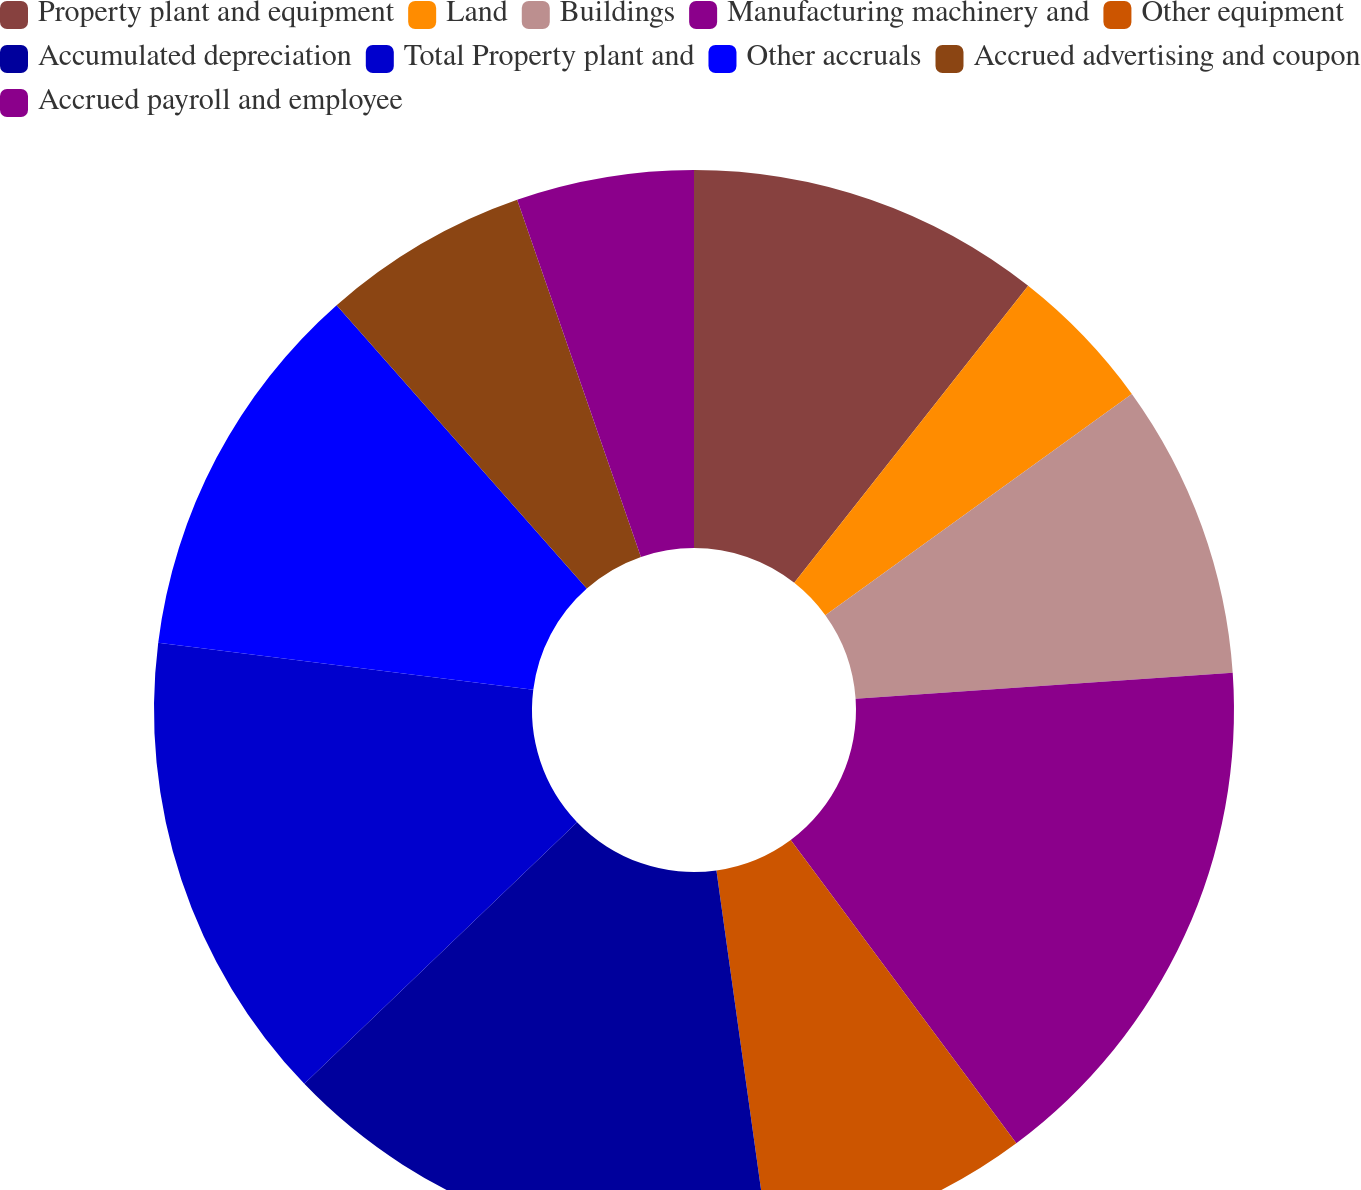<chart> <loc_0><loc_0><loc_500><loc_500><pie_chart><fcel>Property plant and equipment<fcel>Land<fcel>Buildings<fcel>Manufacturing machinery and<fcel>Other equipment<fcel>Accumulated depreciation<fcel>Total Property plant and<fcel>Other accruals<fcel>Accrued advertising and coupon<fcel>Accrued payroll and employee<nl><fcel>10.62%<fcel>4.43%<fcel>8.85%<fcel>15.92%<fcel>7.97%<fcel>15.04%<fcel>14.16%<fcel>11.5%<fcel>6.2%<fcel>5.31%<nl></chart> 